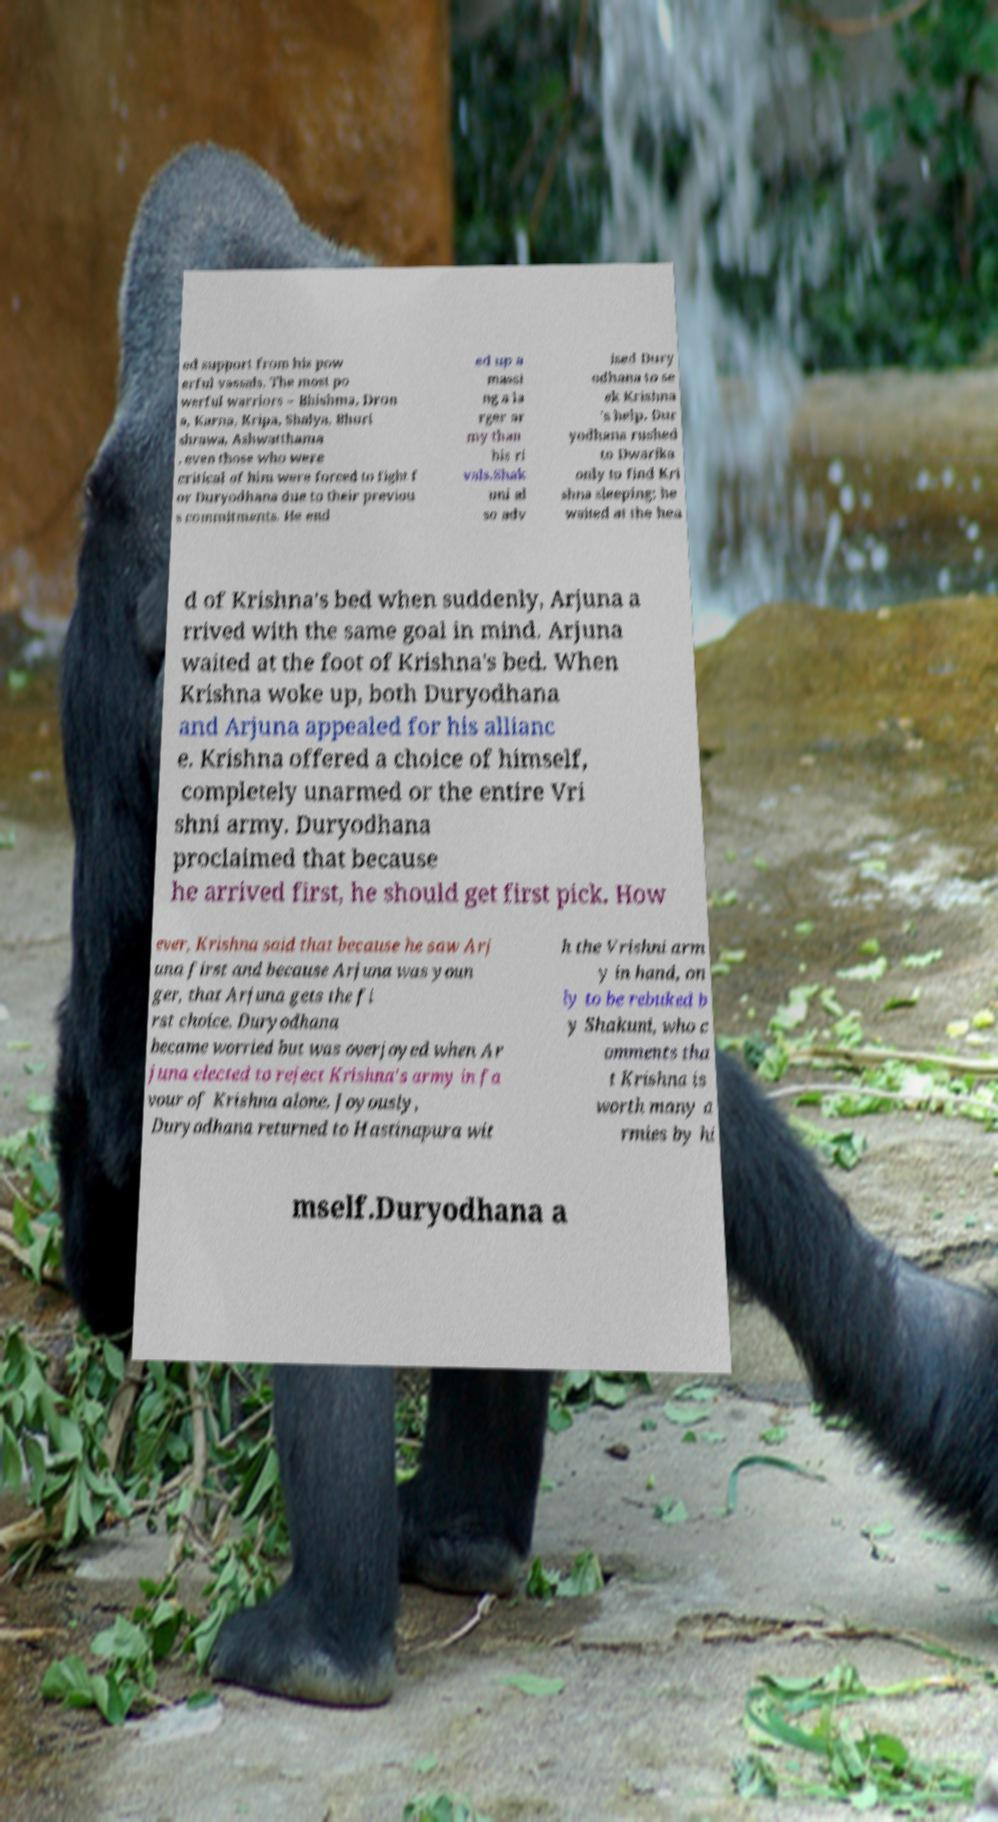What messages or text are displayed in this image? I need them in a readable, typed format. ed support from his pow erful vassals. The most po werful warriors – Bhishma, Dron a, Karna, Kripa, Shalya, Bhuri shrawa, Ashwatthama , even those who were critical of him were forced to fight f or Duryodhana due to their previou s commitments. He end ed up a massi ng a la rger ar my than his ri vals.Shak uni al so adv ised Dury odhana to se ek Krishna 's help. Dur yodhana rushed to Dwarika only to find Kri shna sleeping; he waited at the hea d of Krishna's bed when suddenly, Arjuna a rrived with the same goal in mind. Arjuna waited at the foot of Krishna's bed. When Krishna woke up, both Duryodhana and Arjuna appealed for his allianc e. Krishna offered a choice of himself, completely unarmed or the entire Vri shni army. Duryodhana proclaimed that because he arrived first, he should get first pick. How ever, Krishna said that because he saw Arj una first and because Arjuna was youn ger, that Arjuna gets the fi rst choice. Duryodhana became worried but was overjoyed when Ar juna elected to reject Krishna's army in fa vour of Krishna alone. Joyously, Duryodhana returned to Hastinapura wit h the Vrishni arm y in hand, on ly to be rebuked b y Shakuni, who c omments tha t Krishna is worth many a rmies by hi mself.Duryodhana a 